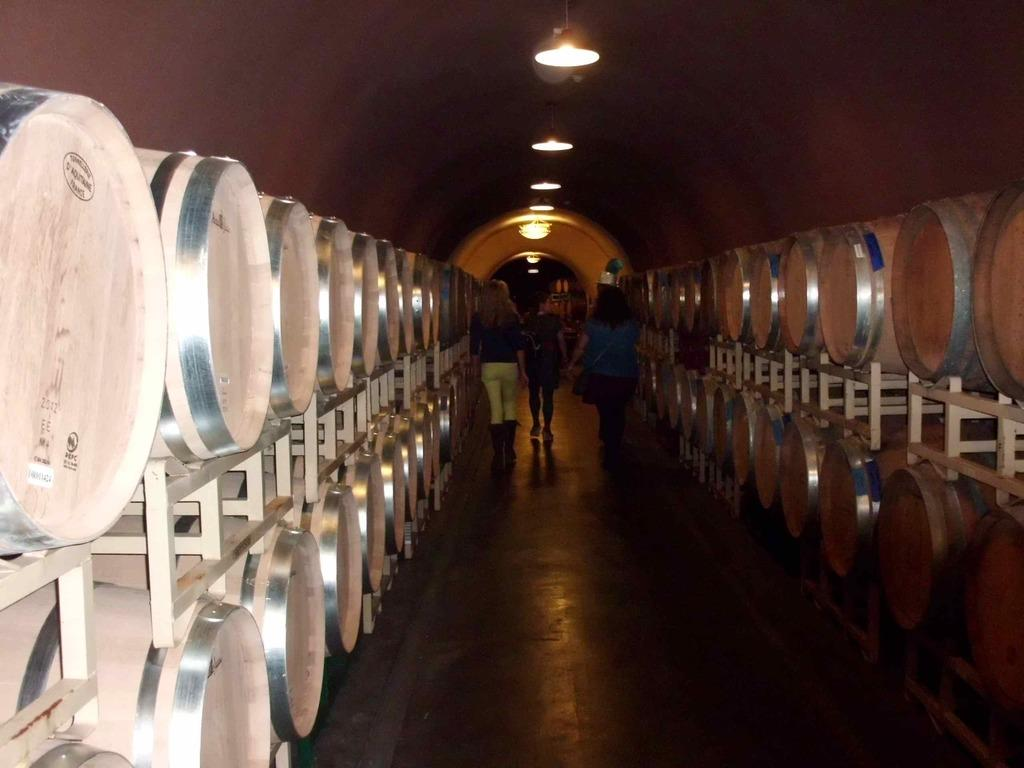How many people can be seen walking in the image? There are three people walking in the image. What surface are the people walking on? The people are walking on the floor. What objects can be seen in addition to the people walking? There are barrels visible in the image. What is located at the top of the image? There are lights at the top of the image. What type of linen is being used by the people walking in the image? There is no mention of linen in the image, and the people walking are not using any linen. 